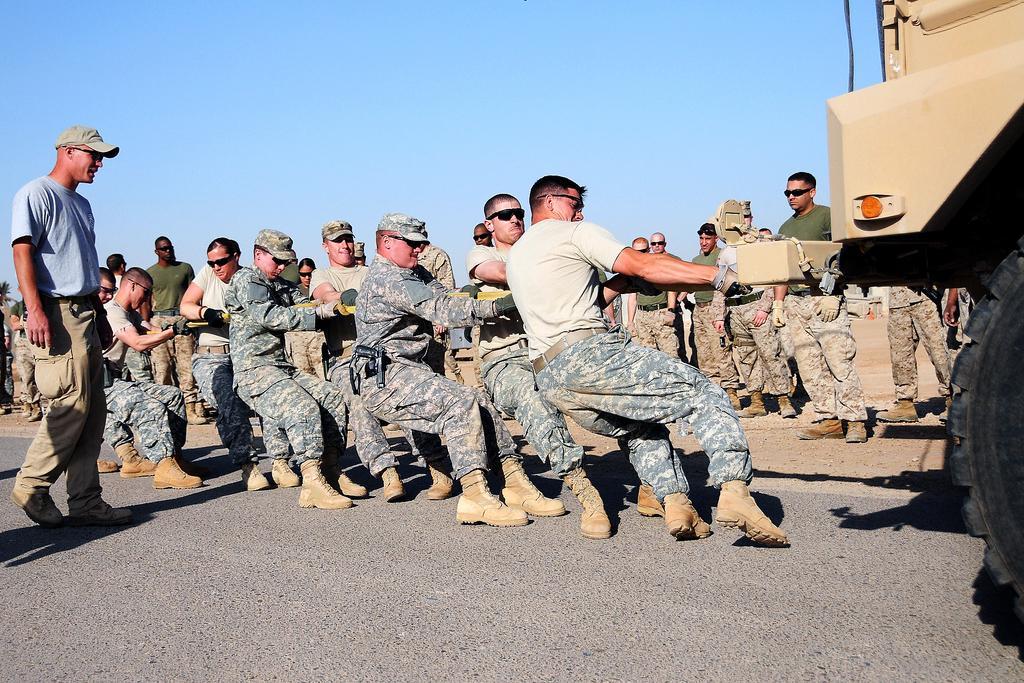Please provide a concise description of this image. In this image we can see a group of people pulling a vehicle. There is a vehicle at the right side of the image. We can see many people standing in the image. We can see few people wearing caps in the image. We can see the sky in the image. 